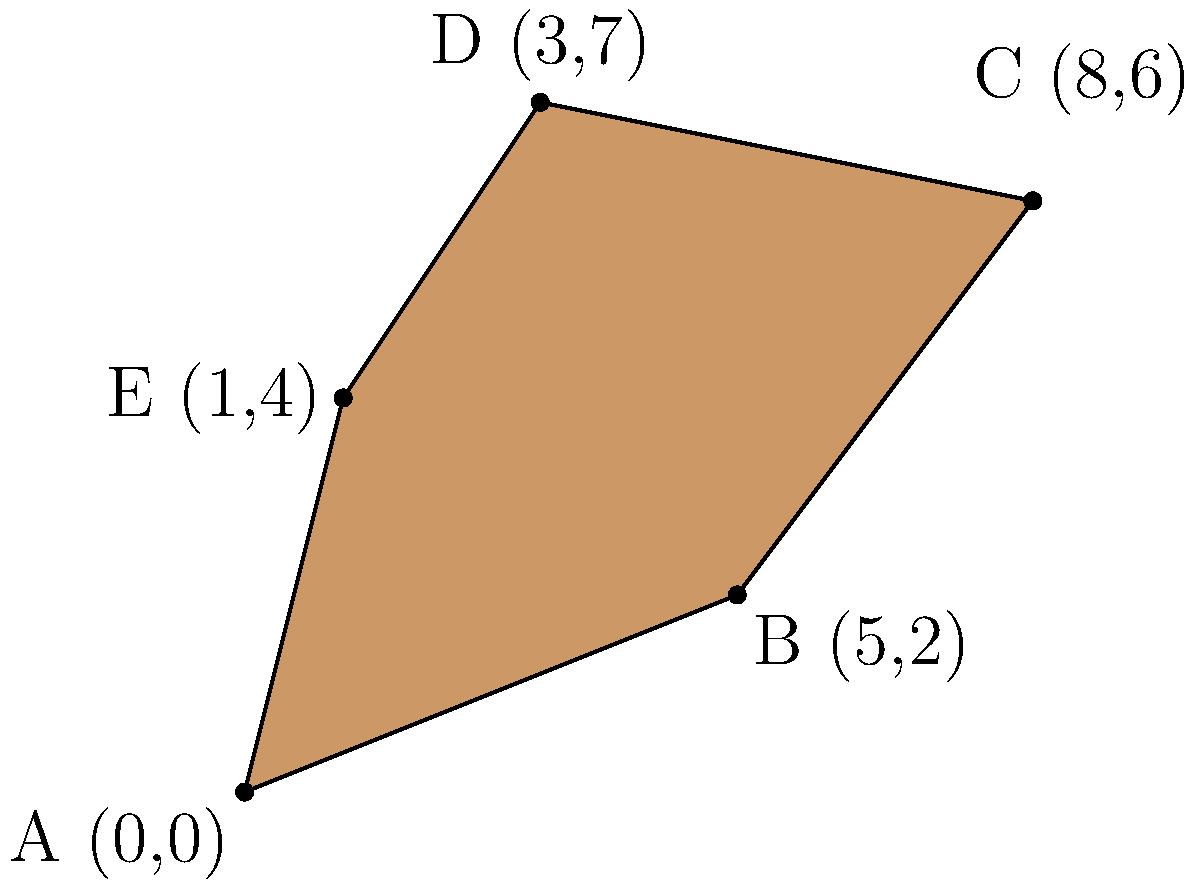As a geographer working on an archaeological site in southeastern Turkey, you've been tasked with calculating the area of an irregularly shaped excavation area. The site's boundaries are defined by five coordinate points: A(0,0), B(5,2), C(8,6), D(3,7), and E(1,4). Using coordinate geometry, determine the area of this archaeological site in square units. To find the area of this irregular polygon, we can use the Shoelace formula (also known as the surveyor's formula). The steps are as follows:

1) First, let's arrange the coordinates in order:
   (0,0), (5,2), (8,6), (3,7), (1,4)

2) The Shoelace formula is:
   $$Area = \frac{1}{2}|(x_1y_2 + x_2y_3 + ... + x_ny_1) - (y_1x_2 + y_2x_3 + ... + y_nx_1)|$$

3) Let's calculate each part:
   $$(x_1y_2 + x_2y_3 + ... + x_ny_1) = (0 \cdot 2) + (5 \cdot 6) + (8 \cdot 7) + (3 \cdot 4) + (1 \cdot 0) = 0 + 30 + 56 + 12 + 0 = 98$$

   $$(y_1x_2 + y_2x_3 + ... + y_nx_1) = (0 \cdot 5) + (2 \cdot 8) + (6 \cdot 3) + (7 \cdot 1) + (4 \cdot 0) = 0 + 16 + 18 + 7 + 0 = 41$$

4) Now, let's subtract and take the absolute value:
   $$|98 - 41| = 57$$

5) Finally, divide by 2:
   $$Area = \frac{1}{2} \cdot 57 = 28.5$$

Therefore, the area of the archaeological site is 28.5 square units.
Answer: 28.5 square units 